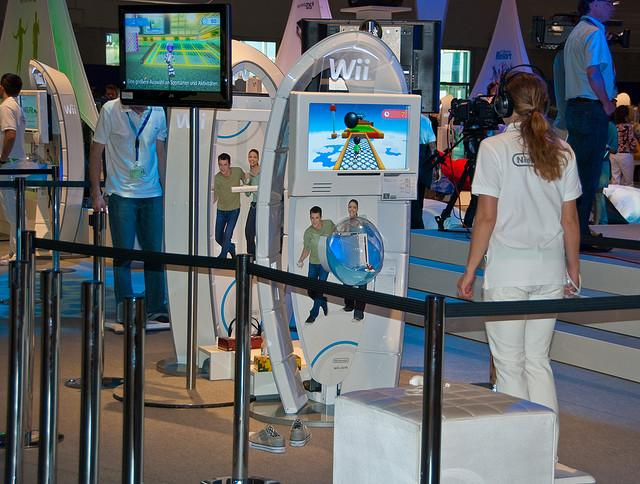What is the article of clothing at the base of the console used for? Please explain your reasoning. walking. The clothing is for walking. 